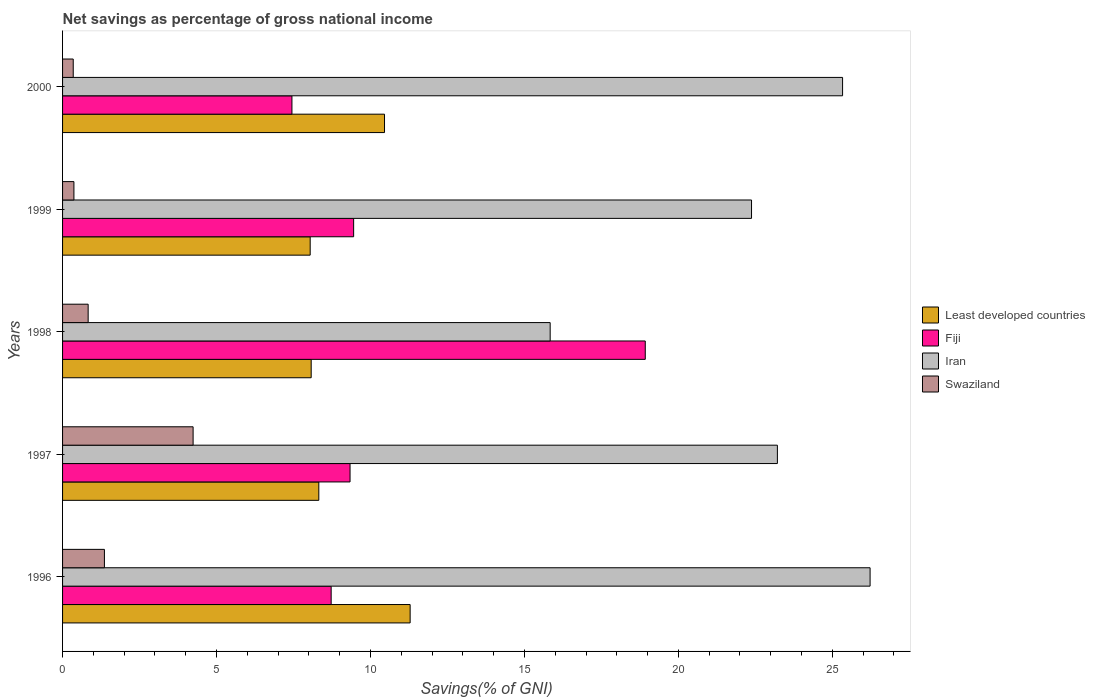How many groups of bars are there?
Keep it short and to the point. 5. Are the number of bars on each tick of the Y-axis equal?
Give a very brief answer. Yes. How many bars are there on the 1st tick from the top?
Ensure brevity in your answer.  4. How many bars are there on the 1st tick from the bottom?
Ensure brevity in your answer.  4. What is the total savings in Fiji in 1998?
Provide a succinct answer. 18.92. Across all years, what is the maximum total savings in Iran?
Ensure brevity in your answer.  26.23. Across all years, what is the minimum total savings in Least developed countries?
Make the answer very short. 8.04. What is the total total savings in Fiji in the graph?
Provide a succinct answer. 53.89. What is the difference between the total savings in Swaziland in 1998 and that in 2000?
Offer a very short reply. 0.48. What is the difference between the total savings in Iran in 2000 and the total savings in Fiji in 1997?
Your answer should be very brief. 16. What is the average total savings in Least developed countries per year?
Provide a succinct answer. 9.24. In the year 2000, what is the difference between the total savings in Swaziland and total savings in Least developed countries?
Provide a succinct answer. -10.11. In how many years, is the total savings in Fiji greater than 3 %?
Provide a short and direct response. 5. What is the ratio of the total savings in Least developed countries in 1998 to that in 2000?
Give a very brief answer. 0.77. Is the total savings in Fiji in 1996 less than that in 1999?
Provide a short and direct response. Yes. What is the difference between the highest and the second highest total savings in Swaziland?
Offer a terse response. 2.88. What is the difference between the highest and the lowest total savings in Iran?
Your response must be concise. 10.39. In how many years, is the total savings in Swaziland greater than the average total savings in Swaziland taken over all years?
Your response must be concise. 1. Is the sum of the total savings in Least developed countries in 1997 and 1999 greater than the maximum total savings in Swaziland across all years?
Offer a terse response. Yes. What does the 2nd bar from the top in 1996 represents?
Offer a terse response. Iran. What does the 1st bar from the bottom in 1998 represents?
Your answer should be compact. Least developed countries. How many legend labels are there?
Your answer should be very brief. 4. How are the legend labels stacked?
Your answer should be compact. Vertical. What is the title of the graph?
Make the answer very short. Net savings as percentage of gross national income. What is the label or title of the X-axis?
Provide a succinct answer. Savings(% of GNI). What is the Savings(% of GNI) in Least developed countries in 1996?
Provide a short and direct response. 11.29. What is the Savings(% of GNI) in Fiji in 1996?
Keep it short and to the point. 8.72. What is the Savings(% of GNI) in Iran in 1996?
Ensure brevity in your answer.  26.23. What is the Savings(% of GNI) of Swaziland in 1996?
Keep it short and to the point. 1.36. What is the Savings(% of GNI) of Least developed countries in 1997?
Ensure brevity in your answer.  8.32. What is the Savings(% of GNI) in Fiji in 1997?
Give a very brief answer. 9.34. What is the Savings(% of GNI) of Iran in 1997?
Ensure brevity in your answer.  23.21. What is the Savings(% of GNI) of Swaziland in 1997?
Provide a succinct answer. 4.24. What is the Savings(% of GNI) of Least developed countries in 1998?
Give a very brief answer. 8.07. What is the Savings(% of GNI) in Fiji in 1998?
Provide a short and direct response. 18.92. What is the Savings(% of GNI) of Iran in 1998?
Offer a very short reply. 15.84. What is the Savings(% of GNI) in Swaziland in 1998?
Your answer should be compact. 0.83. What is the Savings(% of GNI) in Least developed countries in 1999?
Your response must be concise. 8.04. What is the Savings(% of GNI) in Fiji in 1999?
Make the answer very short. 9.45. What is the Savings(% of GNI) in Iran in 1999?
Offer a very short reply. 22.38. What is the Savings(% of GNI) of Swaziland in 1999?
Your answer should be compact. 0.37. What is the Savings(% of GNI) in Least developed countries in 2000?
Offer a very short reply. 10.46. What is the Savings(% of GNI) in Fiji in 2000?
Ensure brevity in your answer.  7.45. What is the Savings(% of GNI) in Iran in 2000?
Your answer should be compact. 25.33. What is the Savings(% of GNI) in Swaziland in 2000?
Provide a short and direct response. 0.35. Across all years, what is the maximum Savings(% of GNI) of Least developed countries?
Give a very brief answer. 11.29. Across all years, what is the maximum Savings(% of GNI) of Fiji?
Give a very brief answer. 18.92. Across all years, what is the maximum Savings(% of GNI) in Iran?
Make the answer very short. 26.23. Across all years, what is the maximum Savings(% of GNI) of Swaziland?
Make the answer very short. 4.24. Across all years, what is the minimum Savings(% of GNI) of Least developed countries?
Your response must be concise. 8.04. Across all years, what is the minimum Savings(% of GNI) of Fiji?
Your answer should be compact. 7.45. Across all years, what is the minimum Savings(% of GNI) of Iran?
Provide a succinct answer. 15.84. Across all years, what is the minimum Savings(% of GNI) in Swaziland?
Provide a succinct answer. 0.35. What is the total Savings(% of GNI) in Least developed countries in the graph?
Ensure brevity in your answer.  46.18. What is the total Savings(% of GNI) of Fiji in the graph?
Offer a very short reply. 53.89. What is the total Savings(% of GNI) in Iran in the graph?
Give a very brief answer. 112.98. What is the total Savings(% of GNI) of Swaziland in the graph?
Give a very brief answer. 7.15. What is the difference between the Savings(% of GNI) in Least developed countries in 1996 and that in 1997?
Keep it short and to the point. 2.97. What is the difference between the Savings(% of GNI) in Fiji in 1996 and that in 1997?
Offer a very short reply. -0.61. What is the difference between the Savings(% of GNI) in Iran in 1996 and that in 1997?
Your answer should be compact. 3.01. What is the difference between the Savings(% of GNI) in Swaziland in 1996 and that in 1997?
Your answer should be compact. -2.88. What is the difference between the Savings(% of GNI) of Least developed countries in 1996 and that in 1998?
Keep it short and to the point. 3.21. What is the difference between the Savings(% of GNI) in Fiji in 1996 and that in 1998?
Give a very brief answer. -10.2. What is the difference between the Savings(% of GNI) of Iran in 1996 and that in 1998?
Give a very brief answer. 10.39. What is the difference between the Savings(% of GNI) of Swaziland in 1996 and that in 1998?
Your answer should be very brief. 0.53. What is the difference between the Savings(% of GNI) of Least developed countries in 1996 and that in 1999?
Make the answer very short. 3.25. What is the difference between the Savings(% of GNI) of Fiji in 1996 and that in 1999?
Your response must be concise. -0.73. What is the difference between the Savings(% of GNI) of Iran in 1996 and that in 1999?
Ensure brevity in your answer.  3.85. What is the difference between the Savings(% of GNI) in Least developed countries in 1996 and that in 2000?
Your answer should be very brief. 0.83. What is the difference between the Savings(% of GNI) of Fiji in 1996 and that in 2000?
Offer a very short reply. 1.27. What is the difference between the Savings(% of GNI) in Iran in 1996 and that in 2000?
Your answer should be compact. 0.89. What is the difference between the Savings(% of GNI) of Swaziland in 1996 and that in 2000?
Ensure brevity in your answer.  1.01. What is the difference between the Savings(% of GNI) of Least developed countries in 1997 and that in 1998?
Give a very brief answer. 0.25. What is the difference between the Savings(% of GNI) of Fiji in 1997 and that in 1998?
Offer a terse response. -9.59. What is the difference between the Savings(% of GNI) of Iran in 1997 and that in 1998?
Ensure brevity in your answer.  7.38. What is the difference between the Savings(% of GNI) in Swaziland in 1997 and that in 1998?
Offer a terse response. 3.41. What is the difference between the Savings(% of GNI) in Least developed countries in 1997 and that in 1999?
Keep it short and to the point. 0.28. What is the difference between the Savings(% of GNI) in Fiji in 1997 and that in 1999?
Make the answer very short. -0.12. What is the difference between the Savings(% of GNI) in Iran in 1997 and that in 1999?
Make the answer very short. 0.84. What is the difference between the Savings(% of GNI) in Swaziland in 1997 and that in 1999?
Provide a short and direct response. 3.87. What is the difference between the Savings(% of GNI) in Least developed countries in 1997 and that in 2000?
Offer a very short reply. -2.13. What is the difference between the Savings(% of GNI) of Fiji in 1997 and that in 2000?
Provide a succinct answer. 1.89. What is the difference between the Savings(% of GNI) of Iran in 1997 and that in 2000?
Offer a terse response. -2.12. What is the difference between the Savings(% of GNI) in Swaziland in 1997 and that in 2000?
Your response must be concise. 3.89. What is the difference between the Savings(% of GNI) in Least developed countries in 1998 and that in 1999?
Your response must be concise. 0.03. What is the difference between the Savings(% of GNI) in Fiji in 1998 and that in 1999?
Give a very brief answer. 9.47. What is the difference between the Savings(% of GNI) in Iran in 1998 and that in 1999?
Your answer should be very brief. -6.54. What is the difference between the Savings(% of GNI) of Swaziland in 1998 and that in 1999?
Provide a succinct answer. 0.46. What is the difference between the Savings(% of GNI) of Least developed countries in 1998 and that in 2000?
Your answer should be very brief. -2.38. What is the difference between the Savings(% of GNI) of Fiji in 1998 and that in 2000?
Make the answer very short. 11.48. What is the difference between the Savings(% of GNI) in Iran in 1998 and that in 2000?
Give a very brief answer. -9.5. What is the difference between the Savings(% of GNI) in Swaziland in 1998 and that in 2000?
Keep it short and to the point. 0.48. What is the difference between the Savings(% of GNI) of Least developed countries in 1999 and that in 2000?
Provide a short and direct response. -2.41. What is the difference between the Savings(% of GNI) of Fiji in 1999 and that in 2000?
Your response must be concise. 2. What is the difference between the Savings(% of GNI) of Iran in 1999 and that in 2000?
Offer a terse response. -2.96. What is the difference between the Savings(% of GNI) in Swaziland in 1999 and that in 2000?
Make the answer very short. 0.02. What is the difference between the Savings(% of GNI) of Least developed countries in 1996 and the Savings(% of GNI) of Fiji in 1997?
Offer a terse response. 1.95. What is the difference between the Savings(% of GNI) in Least developed countries in 1996 and the Savings(% of GNI) in Iran in 1997?
Your response must be concise. -11.93. What is the difference between the Savings(% of GNI) in Least developed countries in 1996 and the Savings(% of GNI) in Swaziland in 1997?
Offer a very short reply. 7.05. What is the difference between the Savings(% of GNI) in Fiji in 1996 and the Savings(% of GNI) in Iran in 1997?
Your answer should be very brief. -14.49. What is the difference between the Savings(% of GNI) of Fiji in 1996 and the Savings(% of GNI) of Swaziland in 1997?
Your answer should be very brief. 4.48. What is the difference between the Savings(% of GNI) in Iran in 1996 and the Savings(% of GNI) in Swaziland in 1997?
Ensure brevity in your answer.  21.99. What is the difference between the Savings(% of GNI) in Least developed countries in 1996 and the Savings(% of GNI) in Fiji in 1998?
Provide a short and direct response. -7.64. What is the difference between the Savings(% of GNI) in Least developed countries in 1996 and the Savings(% of GNI) in Iran in 1998?
Make the answer very short. -4.55. What is the difference between the Savings(% of GNI) in Least developed countries in 1996 and the Savings(% of GNI) in Swaziland in 1998?
Provide a short and direct response. 10.46. What is the difference between the Savings(% of GNI) in Fiji in 1996 and the Savings(% of GNI) in Iran in 1998?
Keep it short and to the point. -7.11. What is the difference between the Savings(% of GNI) in Fiji in 1996 and the Savings(% of GNI) in Swaziland in 1998?
Ensure brevity in your answer.  7.89. What is the difference between the Savings(% of GNI) of Iran in 1996 and the Savings(% of GNI) of Swaziland in 1998?
Offer a terse response. 25.39. What is the difference between the Savings(% of GNI) of Least developed countries in 1996 and the Savings(% of GNI) of Fiji in 1999?
Your answer should be compact. 1.84. What is the difference between the Savings(% of GNI) of Least developed countries in 1996 and the Savings(% of GNI) of Iran in 1999?
Keep it short and to the point. -11.09. What is the difference between the Savings(% of GNI) of Least developed countries in 1996 and the Savings(% of GNI) of Swaziland in 1999?
Your answer should be very brief. 10.92. What is the difference between the Savings(% of GNI) in Fiji in 1996 and the Savings(% of GNI) in Iran in 1999?
Make the answer very short. -13.65. What is the difference between the Savings(% of GNI) of Fiji in 1996 and the Savings(% of GNI) of Swaziland in 1999?
Your response must be concise. 8.35. What is the difference between the Savings(% of GNI) in Iran in 1996 and the Savings(% of GNI) in Swaziland in 1999?
Your response must be concise. 25.86. What is the difference between the Savings(% of GNI) of Least developed countries in 1996 and the Savings(% of GNI) of Fiji in 2000?
Make the answer very short. 3.84. What is the difference between the Savings(% of GNI) in Least developed countries in 1996 and the Savings(% of GNI) in Iran in 2000?
Your response must be concise. -14.04. What is the difference between the Savings(% of GNI) in Least developed countries in 1996 and the Savings(% of GNI) in Swaziland in 2000?
Keep it short and to the point. 10.94. What is the difference between the Savings(% of GNI) in Fiji in 1996 and the Savings(% of GNI) in Iran in 2000?
Your answer should be compact. -16.61. What is the difference between the Savings(% of GNI) in Fiji in 1996 and the Savings(% of GNI) in Swaziland in 2000?
Ensure brevity in your answer.  8.38. What is the difference between the Savings(% of GNI) in Iran in 1996 and the Savings(% of GNI) in Swaziland in 2000?
Make the answer very short. 25.88. What is the difference between the Savings(% of GNI) in Least developed countries in 1997 and the Savings(% of GNI) in Fiji in 1998?
Your response must be concise. -10.6. What is the difference between the Savings(% of GNI) of Least developed countries in 1997 and the Savings(% of GNI) of Iran in 1998?
Your answer should be very brief. -7.51. What is the difference between the Savings(% of GNI) in Least developed countries in 1997 and the Savings(% of GNI) in Swaziland in 1998?
Give a very brief answer. 7.49. What is the difference between the Savings(% of GNI) of Fiji in 1997 and the Savings(% of GNI) of Iran in 1998?
Make the answer very short. -6.5. What is the difference between the Savings(% of GNI) in Fiji in 1997 and the Savings(% of GNI) in Swaziland in 1998?
Offer a very short reply. 8.51. What is the difference between the Savings(% of GNI) in Iran in 1997 and the Savings(% of GNI) in Swaziland in 1998?
Your answer should be very brief. 22.38. What is the difference between the Savings(% of GNI) in Least developed countries in 1997 and the Savings(% of GNI) in Fiji in 1999?
Give a very brief answer. -1.13. What is the difference between the Savings(% of GNI) of Least developed countries in 1997 and the Savings(% of GNI) of Iran in 1999?
Your response must be concise. -14.05. What is the difference between the Savings(% of GNI) of Least developed countries in 1997 and the Savings(% of GNI) of Swaziland in 1999?
Your response must be concise. 7.95. What is the difference between the Savings(% of GNI) in Fiji in 1997 and the Savings(% of GNI) in Iran in 1999?
Ensure brevity in your answer.  -13.04. What is the difference between the Savings(% of GNI) of Fiji in 1997 and the Savings(% of GNI) of Swaziland in 1999?
Your response must be concise. 8.97. What is the difference between the Savings(% of GNI) in Iran in 1997 and the Savings(% of GNI) in Swaziland in 1999?
Your answer should be compact. 22.85. What is the difference between the Savings(% of GNI) of Least developed countries in 1997 and the Savings(% of GNI) of Fiji in 2000?
Provide a short and direct response. 0.87. What is the difference between the Savings(% of GNI) of Least developed countries in 1997 and the Savings(% of GNI) of Iran in 2000?
Ensure brevity in your answer.  -17.01. What is the difference between the Savings(% of GNI) in Least developed countries in 1997 and the Savings(% of GNI) in Swaziland in 2000?
Offer a terse response. 7.98. What is the difference between the Savings(% of GNI) in Fiji in 1997 and the Savings(% of GNI) in Iran in 2000?
Your response must be concise. -16. What is the difference between the Savings(% of GNI) in Fiji in 1997 and the Savings(% of GNI) in Swaziland in 2000?
Make the answer very short. 8.99. What is the difference between the Savings(% of GNI) in Iran in 1997 and the Savings(% of GNI) in Swaziland in 2000?
Give a very brief answer. 22.87. What is the difference between the Savings(% of GNI) of Least developed countries in 1998 and the Savings(% of GNI) of Fiji in 1999?
Offer a terse response. -1.38. What is the difference between the Savings(% of GNI) of Least developed countries in 1998 and the Savings(% of GNI) of Iran in 1999?
Offer a very short reply. -14.3. What is the difference between the Savings(% of GNI) of Least developed countries in 1998 and the Savings(% of GNI) of Swaziland in 1999?
Keep it short and to the point. 7.71. What is the difference between the Savings(% of GNI) in Fiji in 1998 and the Savings(% of GNI) in Iran in 1999?
Offer a very short reply. -3.45. What is the difference between the Savings(% of GNI) of Fiji in 1998 and the Savings(% of GNI) of Swaziland in 1999?
Provide a succinct answer. 18.56. What is the difference between the Savings(% of GNI) of Iran in 1998 and the Savings(% of GNI) of Swaziland in 1999?
Keep it short and to the point. 15.47. What is the difference between the Savings(% of GNI) in Least developed countries in 1998 and the Savings(% of GNI) in Fiji in 2000?
Offer a terse response. 0.63. What is the difference between the Savings(% of GNI) in Least developed countries in 1998 and the Savings(% of GNI) in Iran in 2000?
Offer a very short reply. -17.26. What is the difference between the Savings(% of GNI) in Least developed countries in 1998 and the Savings(% of GNI) in Swaziland in 2000?
Provide a short and direct response. 7.73. What is the difference between the Savings(% of GNI) in Fiji in 1998 and the Savings(% of GNI) in Iran in 2000?
Ensure brevity in your answer.  -6.41. What is the difference between the Savings(% of GNI) of Fiji in 1998 and the Savings(% of GNI) of Swaziland in 2000?
Offer a terse response. 18.58. What is the difference between the Savings(% of GNI) in Iran in 1998 and the Savings(% of GNI) in Swaziland in 2000?
Your response must be concise. 15.49. What is the difference between the Savings(% of GNI) in Least developed countries in 1999 and the Savings(% of GNI) in Fiji in 2000?
Give a very brief answer. 0.59. What is the difference between the Savings(% of GNI) in Least developed countries in 1999 and the Savings(% of GNI) in Iran in 2000?
Your answer should be compact. -17.29. What is the difference between the Savings(% of GNI) of Least developed countries in 1999 and the Savings(% of GNI) of Swaziland in 2000?
Your answer should be very brief. 7.7. What is the difference between the Savings(% of GNI) in Fiji in 1999 and the Savings(% of GNI) in Iran in 2000?
Ensure brevity in your answer.  -15.88. What is the difference between the Savings(% of GNI) in Fiji in 1999 and the Savings(% of GNI) in Swaziland in 2000?
Keep it short and to the point. 9.11. What is the difference between the Savings(% of GNI) of Iran in 1999 and the Savings(% of GNI) of Swaziland in 2000?
Your response must be concise. 22.03. What is the average Savings(% of GNI) in Least developed countries per year?
Offer a terse response. 9.24. What is the average Savings(% of GNI) of Fiji per year?
Ensure brevity in your answer.  10.78. What is the average Savings(% of GNI) of Iran per year?
Provide a succinct answer. 22.6. What is the average Savings(% of GNI) in Swaziland per year?
Make the answer very short. 1.43. In the year 1996, what is the difference between the Savings(% of GNI) in Least developed countries and Savings(% of GNI) in Fiji?
Offer a very short reply. 2.57. In the year 1996, what is the difference between the Savings(% of GNI) of Least developed countries and Savings(% of GNI) of Iran?
Make the answer very short. -14.94. In the year 1996, what is the difference between the Savings(% of GNI) of Least developed countries and Savings(% of GNI) of Swaziland?
Provide a succinct answer. 9.93. In the year 1996, what is the difference between the Savings(% of GNI) of Fiji and Savings(% of GNI) of Iran?
Keep it short and to the point. -17.5. In the year 1996, what is the difference between the Savings(% of GNI) of Fiji and Savings(% of GNI) of Swaziland?
Make the answer very short. 7.36. In the year 1996, what is the difference between the Savings(% of GNI) in Iran and Savings(% of GNI) in Swaziland?
Provide a short and direct response. 24.87. In the year 1997, what is the difference between the Savings(% of GNI) in Least developed countries and Savings(% of GNI) in Fiji?
Give a very brief answer. -1.01. In the year 1997, what is the difference between the Savings(% of GNI) of Least developed countries and Savings(% of GNI) of Iran?
Give a very brief answer. -14.89. In the year 1997, what is the difference between the Savings(% of GNI) in Least developed countries and Savings(% of GNI) in Swaziland?
Provide a succinct answer. 4.08. In the year 1997, what is the difference between the Savings(% of GNI) in Fiji and Savings(% of GNI) in Iran?
Make the answer very short. -13.88. In the year 1997, what is the difference between the Savings(% of GNI) in Fiji and Savings(% of GNI) in Swaziland?
Your answer should be very brief. 5.1. In the year 1997, what is the difference between the Savings(% of GNI) in Iran and Savings(% of GNI) in Swaziland?
Your response must be concise. 18.98. In the year 1998, what is the difference between the Savings(% of GNI) in Least developed countries and Savings(% of GNI) in Fiji?
Provide a succinct answer. -10.85. In the year 1998, what is the difference between the Savings(% of GNI) of Least developed countries and Savings(% of GNI) of Iran?
Keep it short and to the point. -7.76. In the year 1998, what is the difference between the Savings(% of GNI) in Least developed countries and Savings(% of GNI) in Swaziland?
Ensure brevity in your answer.  7.24. In the year 1998, what is the difference between the Savings(% of GNI) in Fiji and Savings(% of GNI) in Iran?
Make the answer very short. 3.09. In the year 1998, what is the difference between the Savings(% of GNI) of Fiji and Savings(% of GNI) of Swaziland?
Give a very brief answer. 18.09. In the year 1998, what is the difference between the Savings(% of GNI) of Iran and Savings(% of GNI) of Swaziland?
Ensure brevity in your answer.  15. In the year 1999, what is the difference between the Savings(% of GNI) in Least developed countries and Savings(% of GNI) in Fiji?
Offer a terse response. -1.41. In the year 1999, what is the difference between the Savings(% of GNI) of Least developed countries and Savings(% of GNI) of Iran?
Your response must be concise. -14.33. In the year 1999, what is the difference between the Savings(% of GNI) in Least developed countries and Savings(% of GNI) in Swaziland?
Your answer should be compact. 7.67. In the year 1999, what is the difference between the Savings(% of GNI) in Fiji and Savings(% of GNI) in Iran?
Your response must be concise. -12.92. In the year 1999, what is the difference between the Savings(% of GNI) in Fiji and Savings(% of GNI) in Swaziland?
Provide a short and direct response. 9.08. In the year 1999, what is the difference between the Savings(% of GNI) in Iran and Savings(% of GNI) in Swaziland?
Offer a terse response. 22.01. In the year 2000, what is the difference between the Savings(% of GNI) in Least developed countries and Savings(% of GNI) in Fiji?
Make the answer very short. 3.01. In the year 2000, what is the difference between the Savings(% of GNI) in Least developed countries and Savings(% of GNI) in Iran?
Ensure brevity in your answer.  -14.88. In the year 2000, what is the difference between the Savings(% of GNI) in Least developed countries and Savings(% of GNI) in Swaziland?
Provide a succinct answer. 10.11. In the year 2000, what is the difference between the Savings(% of GNI) of Fiji and Savings(% of GNI) of Iran?
Offer a very short reply. -17.88. In the year 2000, what is the difference between the Savings(% of GNI) in Fiji and Savings(% of GNI) in Swaziland?
Provide a short and direct response. 7.1. In the year 2000, what is the difference between the Savings(% of GNI) in Iran and Savings(% of GNI) in Swaziland?
Provide a short and direct response. 24.99. What is the ratio of the Savings(% of GNI) in Least developed countries in 1996 to that in 1997?
Your answer should be very brief. 1.36. What is the ratio of the Savings(% of GNI) of Fiji in 1996 to that in 1997?
Keep it short and to the point. 0.93. What is the ratio of the Savings(% of GNI) in Iran in 1996 to that in 1997?
Make the answer very short. 1.13. What is the ratio of the Savings(% of GNI) of Swaziland in 1996 to that in 1997?
Provide a short and direct response. 0.32. What is the ratio of the Savings(% of GNI) of Least developed countries in 1996 to that in 1998?
Give a very brief answer. 1.4. What is the ratio of the Savings(% of GNI) of Fiji in 1996 to that in 1998?
Provide a succinct answer. 0.46. What is the ratio of the Savings(% of GNI) of Iran in 1996 to that in 1998?
Ensure brevity in your answer.  1.66. What is the ratio of the Savings(% of GNI) of Swaziland in 1996 to that in 1998?
Provide a short and direct response. 1.64. What is the ratio of the Savings(% of GNI) in Least developed countries in 1996 to that in 1999?
Keep it short and to the point. 1.4. What is the ratio of the Savings(% of GNI) of Fiji in 1996 to that in 1999?
Keep it short and to the point. 0.92. What is the ratio of the Savings(% of GNI) in Iran in 1996 to that in 1999?
Your answer should be compact. 1.17. What is the ratio of the Savings(% of GNI) in Swaziland in 1996 to that in 1999?
Your answer should be compact. 3.68. What is the ratio of the Savings(% of GNI) in Least developed countries in 1996 to that in 2000?
Offer a terse response. 1.08. What is the ratio of the Savings(% of GNI) in Fiji in 1996 to that in 2000?
Your response must be concise. 1.17. What is the ratio of the Savings(% of GNI) in Iran in 1996 to that in 2000?
Make the answer very short. 1.04. What is the ratio of the Savings(% of GNI) of Swaziland in 1996 to that in 2000?
Provide a short and direct response. 3.93. What is the ratio of the Savings(% of GNI) of Least developed countries in 1997 to that in 1998?
Your response must be concise. 1.03. What is the ratio of the Savings(% of GNI) in Fiji in 1997 to that in 1998?
Your answer should be very brief. 0.49. What is the ratio of the Savings(% of GNI) of Iran in 1997 to that in 1998?
Provide a short and direct response. 1.47. What is the ratio of the Savings(% of GNI) of Swaziland in 1997 to that in 1998?
Provide a succinct answer. 5.1. What is the ratio of the Savings(% of GNI) in Least developed countries in 1997 to that in 1999?
Make the answer very short. 1.03. What is the ratio of the Savings(% of GNI) in Iran in 1997 to that in 1999?
Keep it short and to the point. 1.04. What is the ratio of the Savings(% of GNI) of Swaziland in 1997 to that in 1999?
Make the answer very short. 11.49. What is the ratio of the Savings(% of GNI) in Least developed countries in 1997 to that in 2000?
Ensure brevity in your answer.  0.8. What is the ratio of the Savings(% of GNI) of Fiji in 1997 to that in 2000?
Make the answer very short. 1.25. What is the ratio of the Savings(% of GNI) of Iran in 1997 to that in 2000?
Your answer should be compact. 0.92. What is the ratio of the Savings(% of GNI) in Swaziland in 1997 to that in 2000?
Your response must be concise. 12.24. What is the ratio of the Savings(% of GNI) of Least developed countries in 1998 to that in 1999?
Give a very brief answer. 1. What is the ratio of the Savings(% of GNI) in Fiji in 1998 to that in 1999?
Ensure brevity in your answer.  2. What is the ratio of the Savings(% of GNI) in Iran in 1998 to that in 1999?
Your answer should be very brief. 0.71. What is the ratio of the Savings(% of GNI) of Swaziland in 1998 to that in 1999?
Ensure brevity in your answer.  2.25. What is the ratio of the Savings(% of GNI) in Least developed countries in 1998 to that in 2000?
Offer a terse response. 0.77. What is the ratio of the Savings(% of GNI) of Fiji in 1998 to that in 2000?
Your answer should be very brief. 2.54. What is the ratio of the Savings(% of GNI) of Iran in 1998 to that in 2000?
Make the answer very short. 0.63. What is the ratio of the Savings(% of GNI) of Swaziland in 1998 to that in 2000?
Make the answer very short. 2.4. What is the ratio of the Savings(% of GNI) of Least developed countries in 1999 to that in 2000?
Offer a very short reply. 0.77. What is the ratio of the Savings(% of GNI) in Fiji in 1999 to that in 2000?
Your answer should be compact. 1.27. What is the ratio of the Savings(% of GNI) of Iran in 1999 to that in 2000?
Make the answer very short. 0.88. What is the ratio of the Savings(% of GNI) in Swaziland in 1999 to that in 2000?
Ensure brevity in your answer.  1.07. What is the difference between the highest and the second highest Savings(% of GNI) of Least developed countries?
Offer a very short reply. 0.83. What is the difference between the highest and the second highest Savings(% of GNI) of Fiji?
Give a very brief answer. 9.47. What is the difference between the highest and the second highest Savings(% of GNI) in Iran?
Make the answer very short. 0.89. What is the difference between the highest and the second highest Savings(% of GNI) of Swaziland?
Your answer should be compact. 2.88. What is the difference between the highest and the lowest Savings(% of GNI) of Least developed countries?
Keep it short and to the point. 3.25. What is the difference between the highest and the lowest Savings(% of GNI) of Fiji?
Offer a terse response. 11.48. What is the difference between the highest and the lowest Savings(% of GNI) in Iran?
Your response must be concise. 10.39. What is the difference between the highest and the lowest Savings(% of GNI) in Swaziland?
Provide a succinct answer. 3.89. 